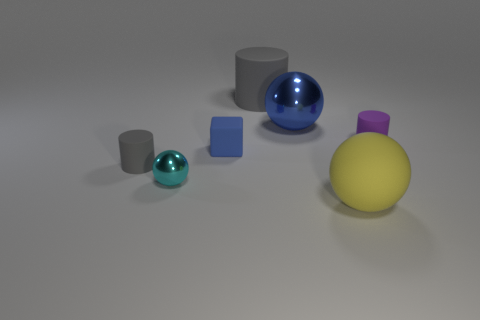Subtract all cyan balls. How many gray cylinders are left? 2 Add 1 small gray things. How many objects exist? 8 Add 3 small rubber things. How many small rubber things are left? 6 Add 3 big balls. How many big balls exist? 5 Subtract 0 cyan blocks. How many objects are left? 7 Subtract all cylinders. How many objects are left? 4 Subtract all big gray matte things. Subtract all tiny gray rubber objects. How many objects are left? 5 